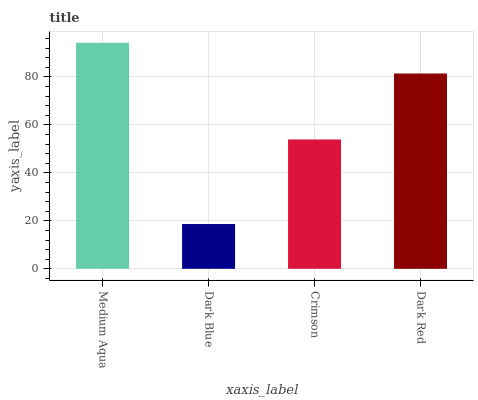Is Dark Blue the minimum?
Answer yes or no. Yes. Is Medium Aqua the maximum?
Answer yes or no. Yes. Is Crimson the minimum?
Answer yes or no. No. Is Crimson the maximum?
Answer yes or no. No. Is Crimson greater than Dark Blue?
Answer yes or no. Yes. Is Dark Blue less than Crimson?
Answer yes or no. Yes. Is Dark Blue greater than Crimson?
Answer yes or no. No. Is Crimson less than Dark Blue?
Answer yes or no. No. Is Dark Red the high median?
Answer yes or no. Yes. Is Crimson the low median?
Answer yes or no. Yes. Is Dark Blue the high median?
Answer yes or no. No. Is Dark Red the low median?
Answer yes or no. No. 